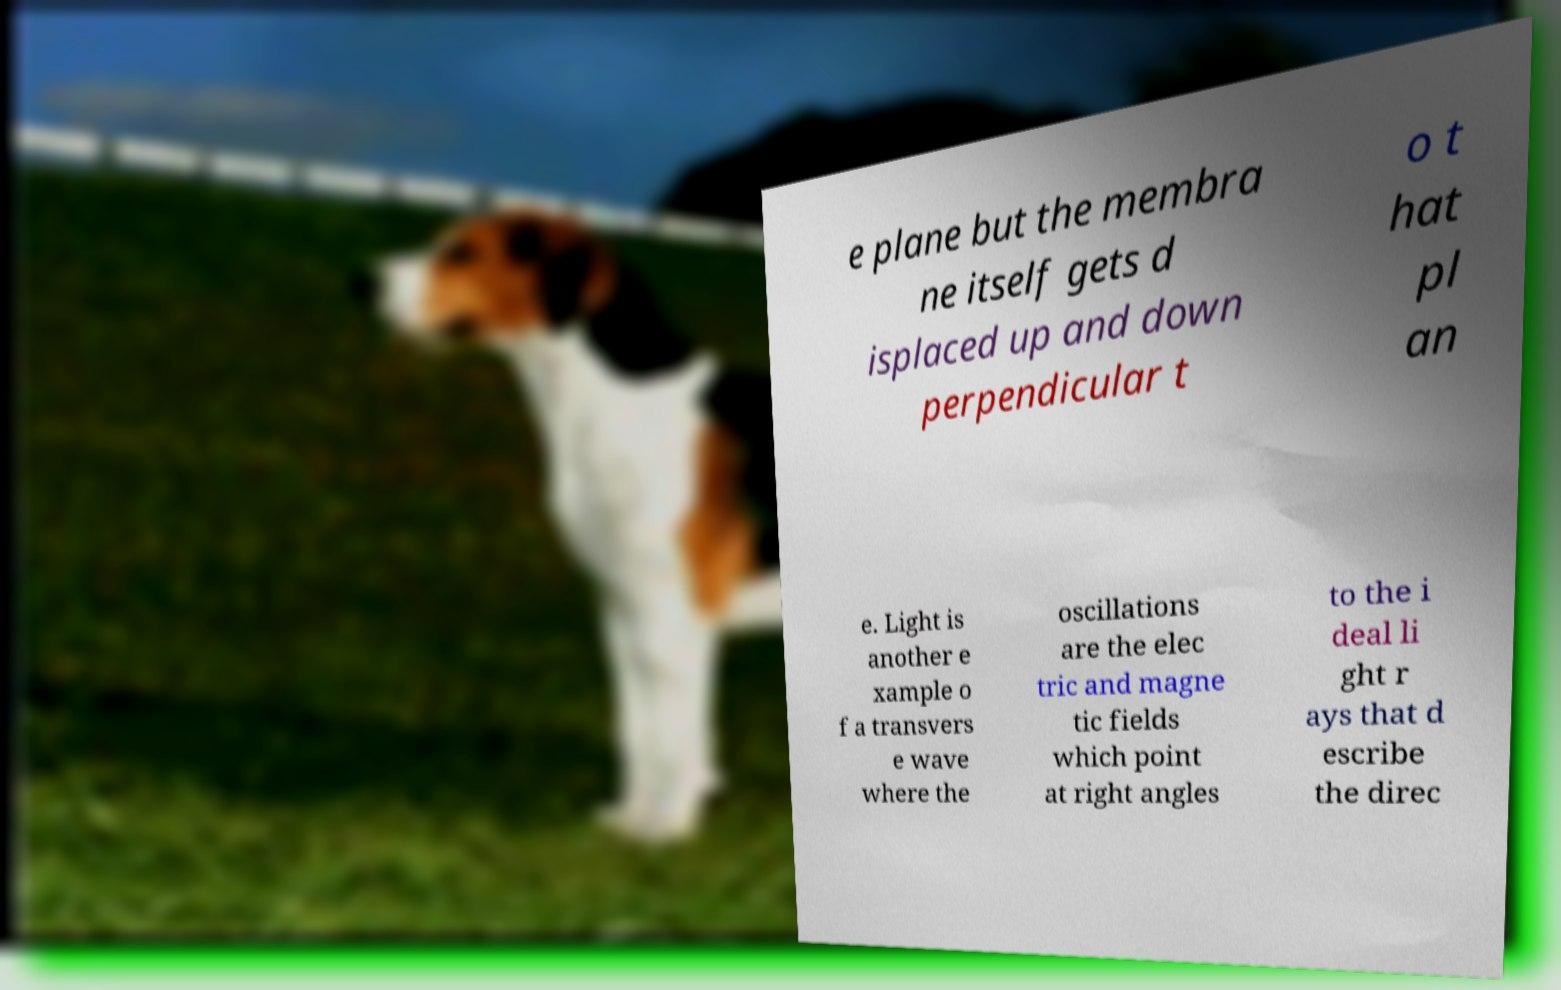Please read and relay the text visible in this image. What does it say? e plane but the membra ne itself gets d isplaced up and down perpendicular t o t hat pl an e. Light is another e xample o f a transvers e wave where the oscillations are the elec tric and magne tic fields which point at right angles to the i deal li ght r ays that d escribe the direc 